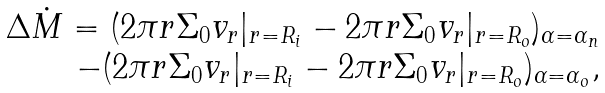<formula> <loc_0><loc_0><loc_500><loc_500>\begin{array} { r l } \Delta \dot { M } = ( 2 \pi r \Sigma _ { 0 } v _ { r } | _ { r = R _ { i } } - 2 \pi r \Sigma _ { 0 } v _ { r } | _ { r = R _ { o } } ) _ { \alpha = \alpha _ { n } } \\ - ( 2 \pi r \Sigma _ { 0 } v _ { r } | _ { r = R _ { i } } - 2 \pi r \Sigma _ { 0 } v _ { r } | _ { r = R _ { o } } ) _ { \alpha = \alpha _ { o } } , \end{array}</formula> 